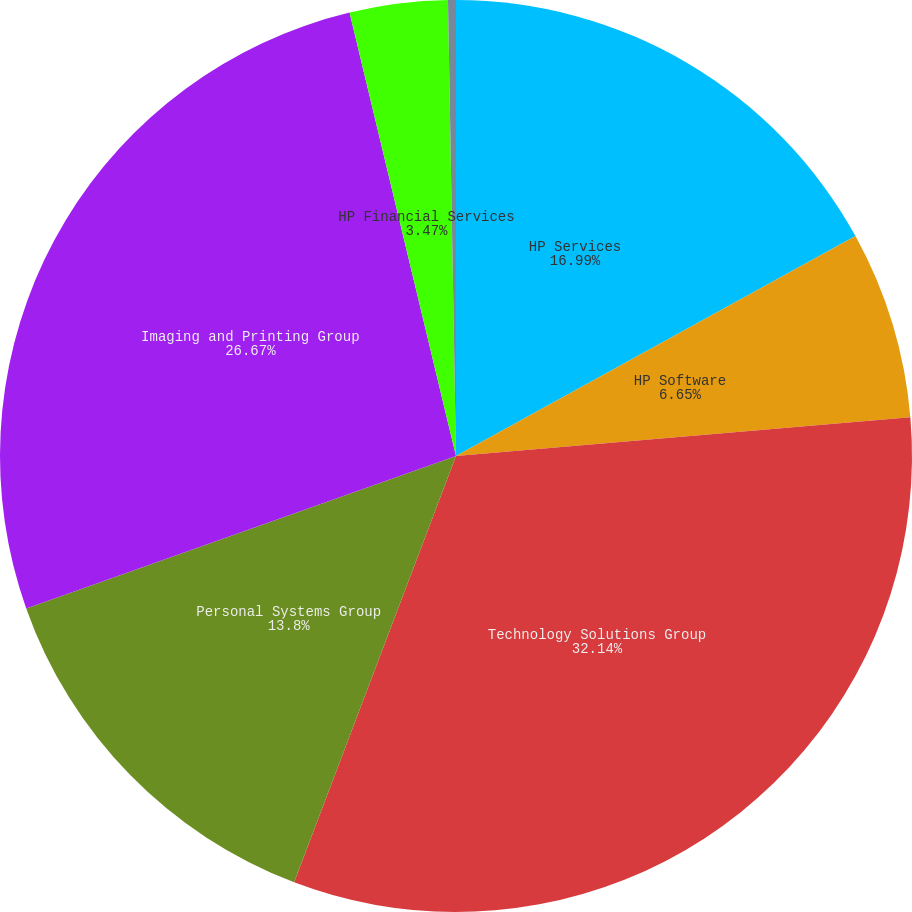Convert chart. <chart><loc_0><loc_0><loc_500><loc_500><pie_chart><fcel>HP Services<fcel>HP Software<fcel>Technology Solutions Group<fcel>Personal Systems Group<fcel>Imaging and Printing Group<fcel>HP Financial Services<fcel>Corporate Investments<nl><fcel>16.99%<fcel>6.65%<fcel>32.13%<fcel>13.8%<fcel>26.67%<fcel>3.47%<fcel>0.28%<nl></chart> 